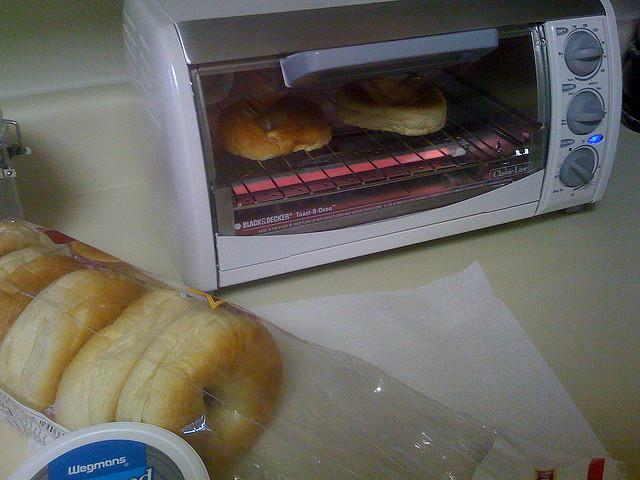Why is the bagel in there?

Choices:
A) warming
B) burning
C) melting
D) toasting toasting 